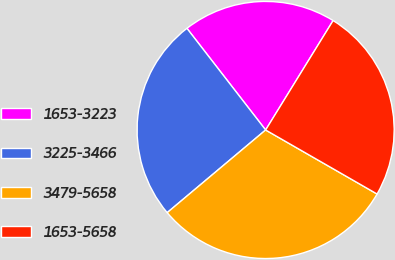Convert chart to OTSL. <chart><loc_0><loc_0><loc_500><loc_500><pie_chart><fcel>1653-3223<fcel>3225-3466<fcel>3479-5658<fcel>1653-5658<nl><fcel>19.28%<fcel>25.63%<fcel>30.58%<fcel>24.5%<nl></chart> 